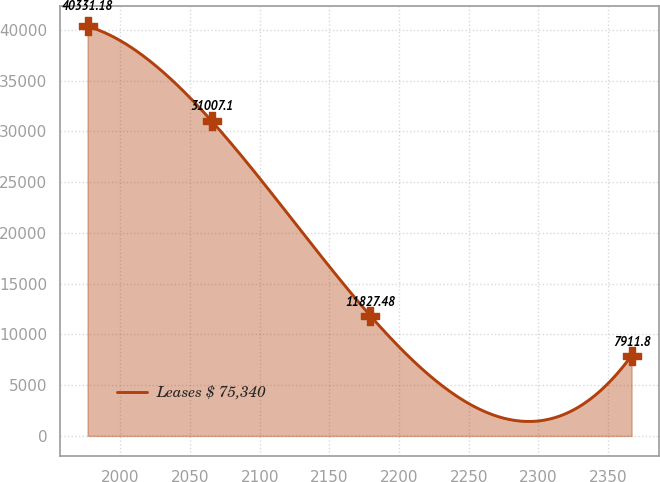Convert chart. <chart><loc_0><loc_0><loc_500><loc_500><line_chart><ecel><fcel>Leases $ 75,340<nl><fcel>1976.54<fcel>40331.2<nl><fcel>2065.59<fcel>31007.1<nl><fcel>2179.44<fcel>11827.5<nl><fcel>2366.77<fcel>7911.8<nl></chart> 